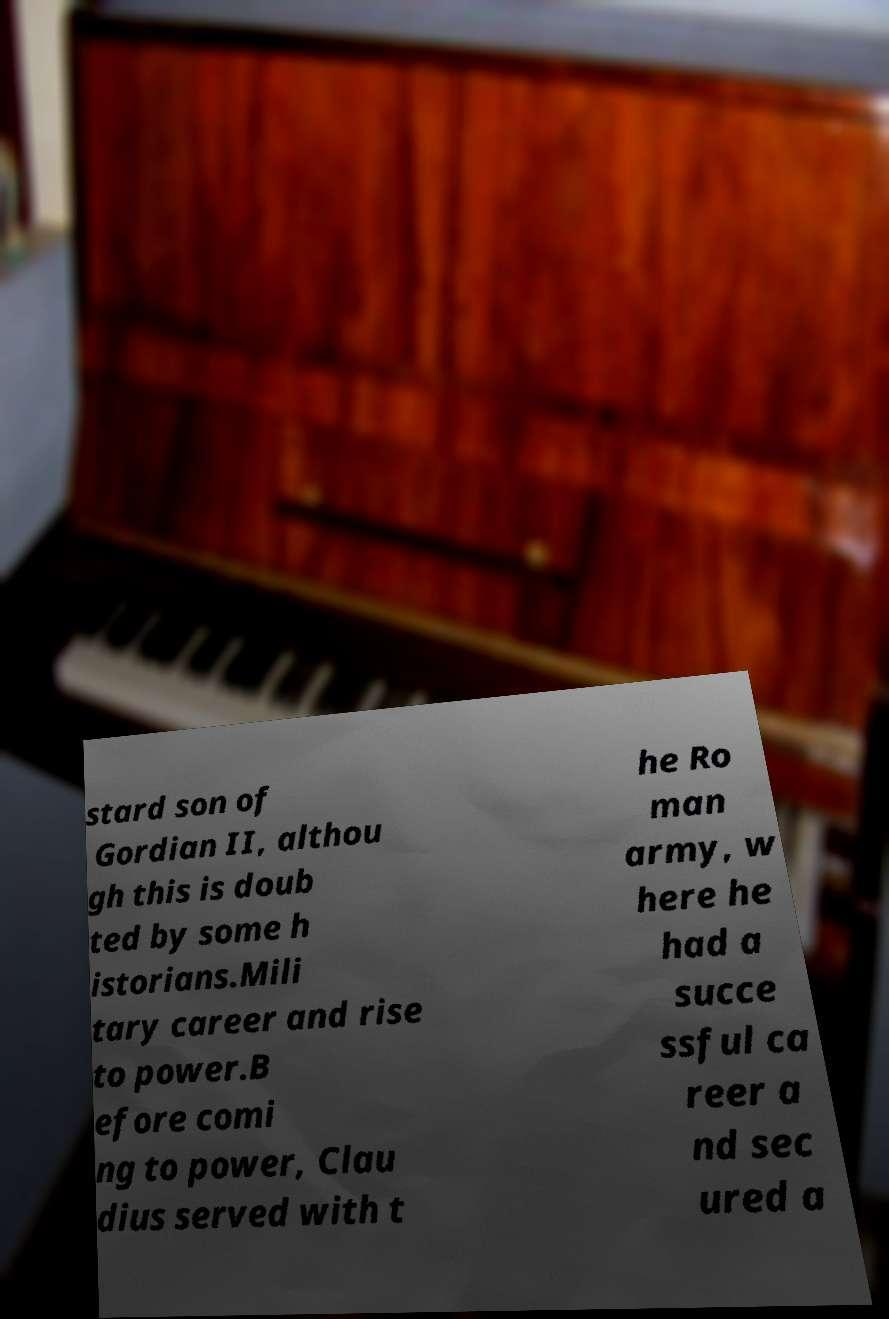Please identify and transcribe the text found in this image. stard son of Gordian II, althou gh this is doub ted by some h istorians.Mili tary career and rise to power.B efore comi ng to power, Clau dius served with t he Ro man army, w here he had a succe ssful ca reer a nd sec ured a 